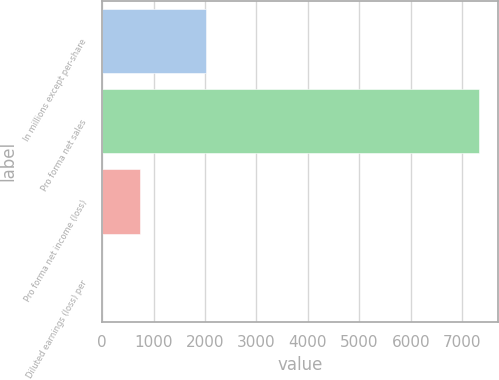<chart> <loc_0><loc_0><loc_500><loc_500><bar_chart><fcel>In millions except per-share<fcel>Pro forma net sales<fcel>Pro forma net income (loss)<fcel>Diluted earnings (loss) per<nl><fcel>2011<fcel>7326.4<fcel>732.85<fcel>0.23<nl></chart> 